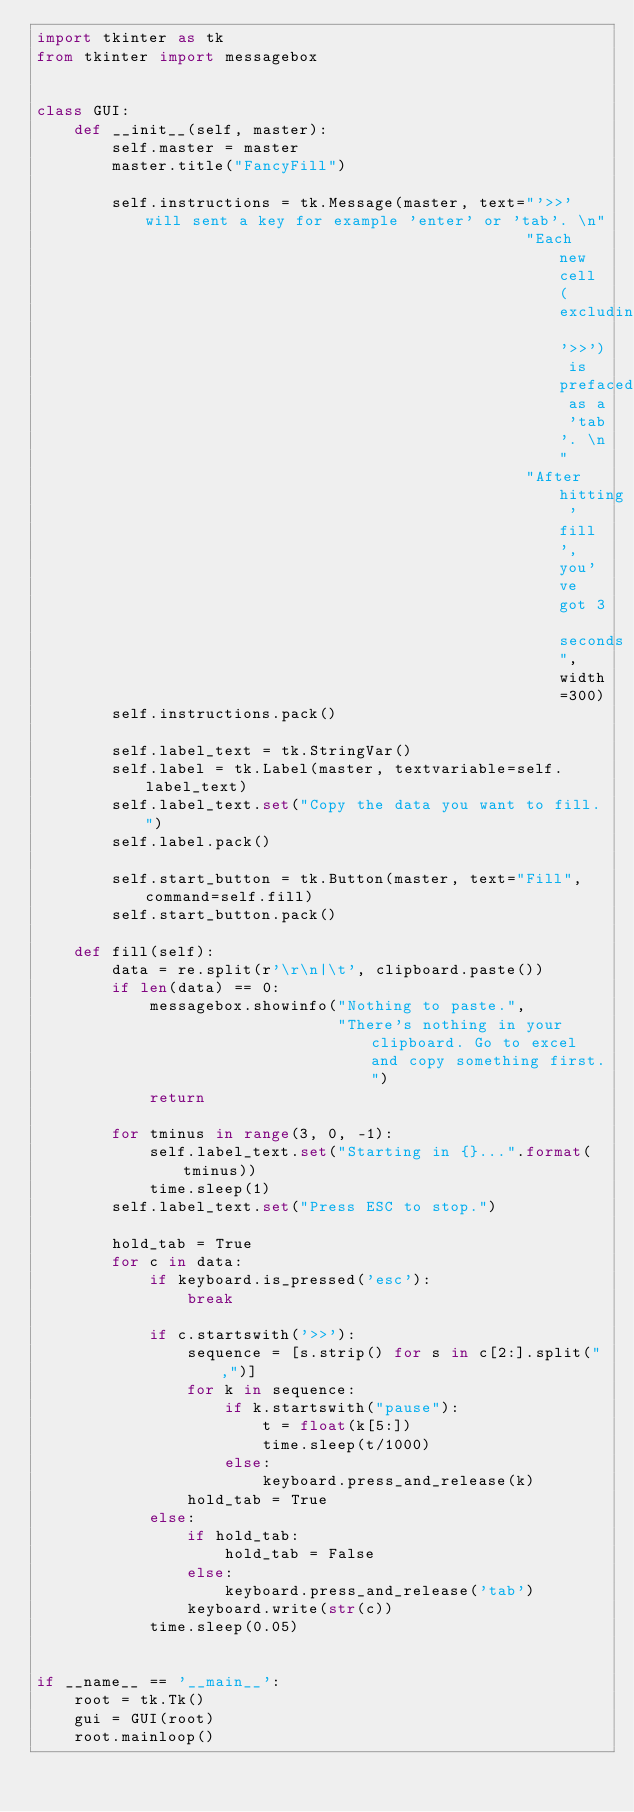Convert code to text. <code><loc_0><loc_0><loc_500><loc_500><_Python_>import tkinter as tk
from tkinter import messagebox


class GUI:
    def __init__(self, master):
        self.master = master
        master.title("FancyFill")

        self.instructions = tk.Message(master, text="'>>' will sent a key for example 'enter' or 'tab'. \n"
                                                    "Each new cell (excluding '>>') is prefaced as a 'tab'. \n"
                                                    "After hitting 'fill', you've got 3 seconds", width=300)
        self.instructions.pack()

        self.label_text = tk.StringVar()
        self.label = tk.Label(master, textvariable=self.label_text)
        self.label_text.set("Copy the data you want to fill.")
        self.label.pack()

        self.start_button = tk.Button(master, text="Fill", command=self.fill)
        self.start_button.pack()

    def fill(self):
        data = re.split(r'\r\n|\t', clipboard.paste())
        if len(data) == 0:
            messagebox.showinfo("Nothing to paste.",
                                "There's nothing in your clipboard. Go to excel and copy something first.")
            return

        for tminus in range(3, 0, -1):
            self.label_text.set("Starting in {}...".format(tminus))
            time.sleep(1)
        self.label_text.set("Press ESC to stop.")

        hold_tab = True
        for c in data:
            if keyboard.is_pressed('esc'):
                break

            if c.startswith('>>'):
                sequence = [s.strip() for s in c[2:].split(",")]
                for k in sequence:
                    if k.startswith("pause"):
                        t = float(k[5:])
                        time.sleep(t/1000)
                    else:
                        keyboard.press_and_release(k)
                hold_tab = True
            else:
                if hold_tab:
                    hold_tab = False
                else:
                    keyboard.press_and_release('tab')
                keyboard.write(str(c))
            time.sleep(0.05)


if __name__ == '__main__':
    root = tk.Tk()
    gui = GUI(root)
    root.mainloop()
</code> 